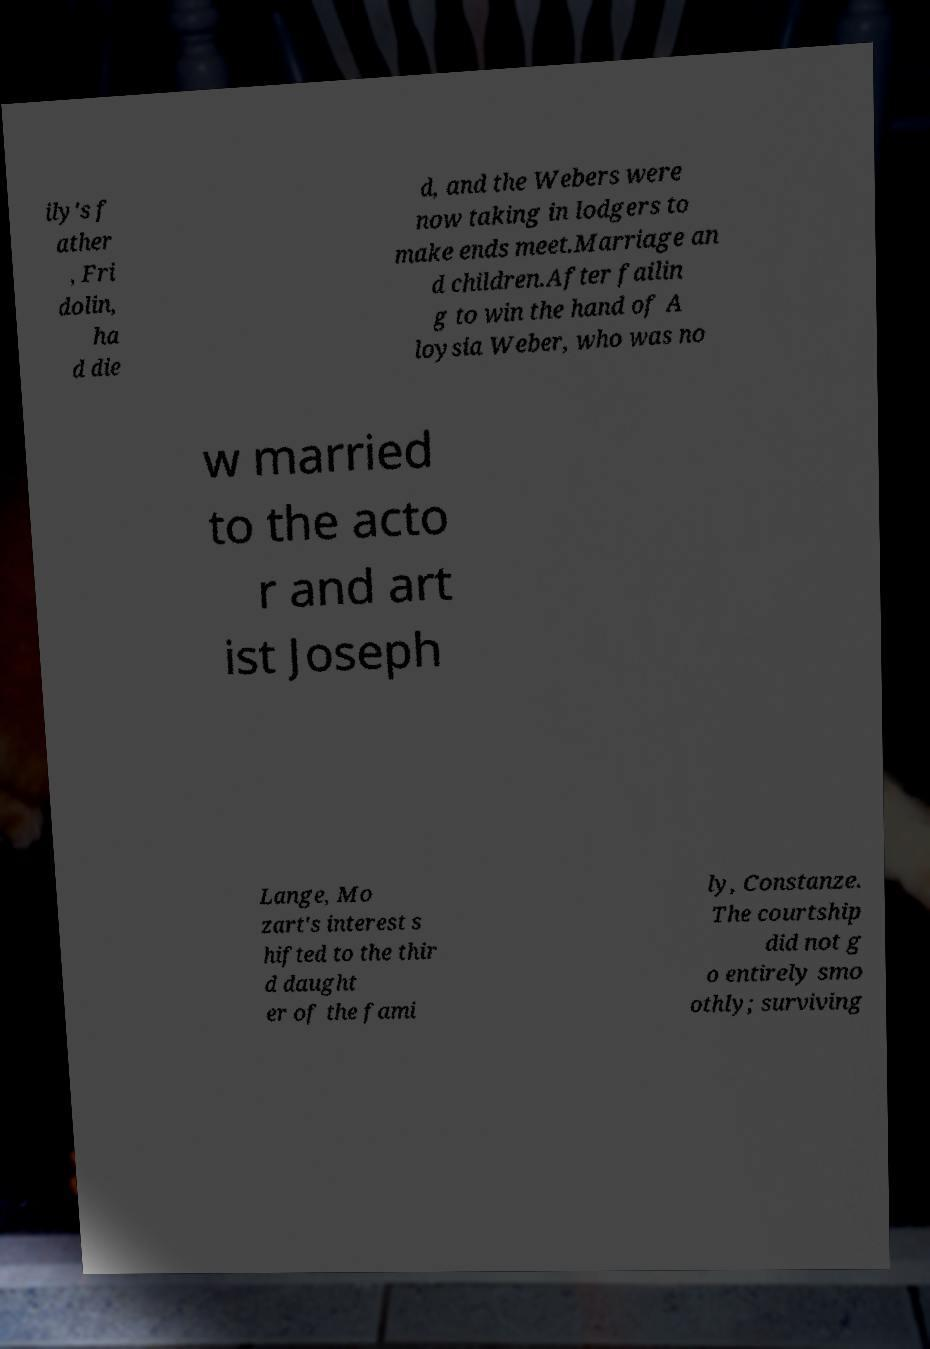Could you assist in decoding the text presented in this image and type it out clearly? ily's f ather , Fri dolin, ha d die d, and the Webers were now taking in lodgers to make ends meet.Marriage an d children.After failin g to win the hand of A loysia Weber, who was no w married to the acto r and art ist Joseph Lange, Mo zart's interest s hifted to the thir d daught er of the fami ly, Constanze. The courtship did not g o entirely smo othly; surviving 